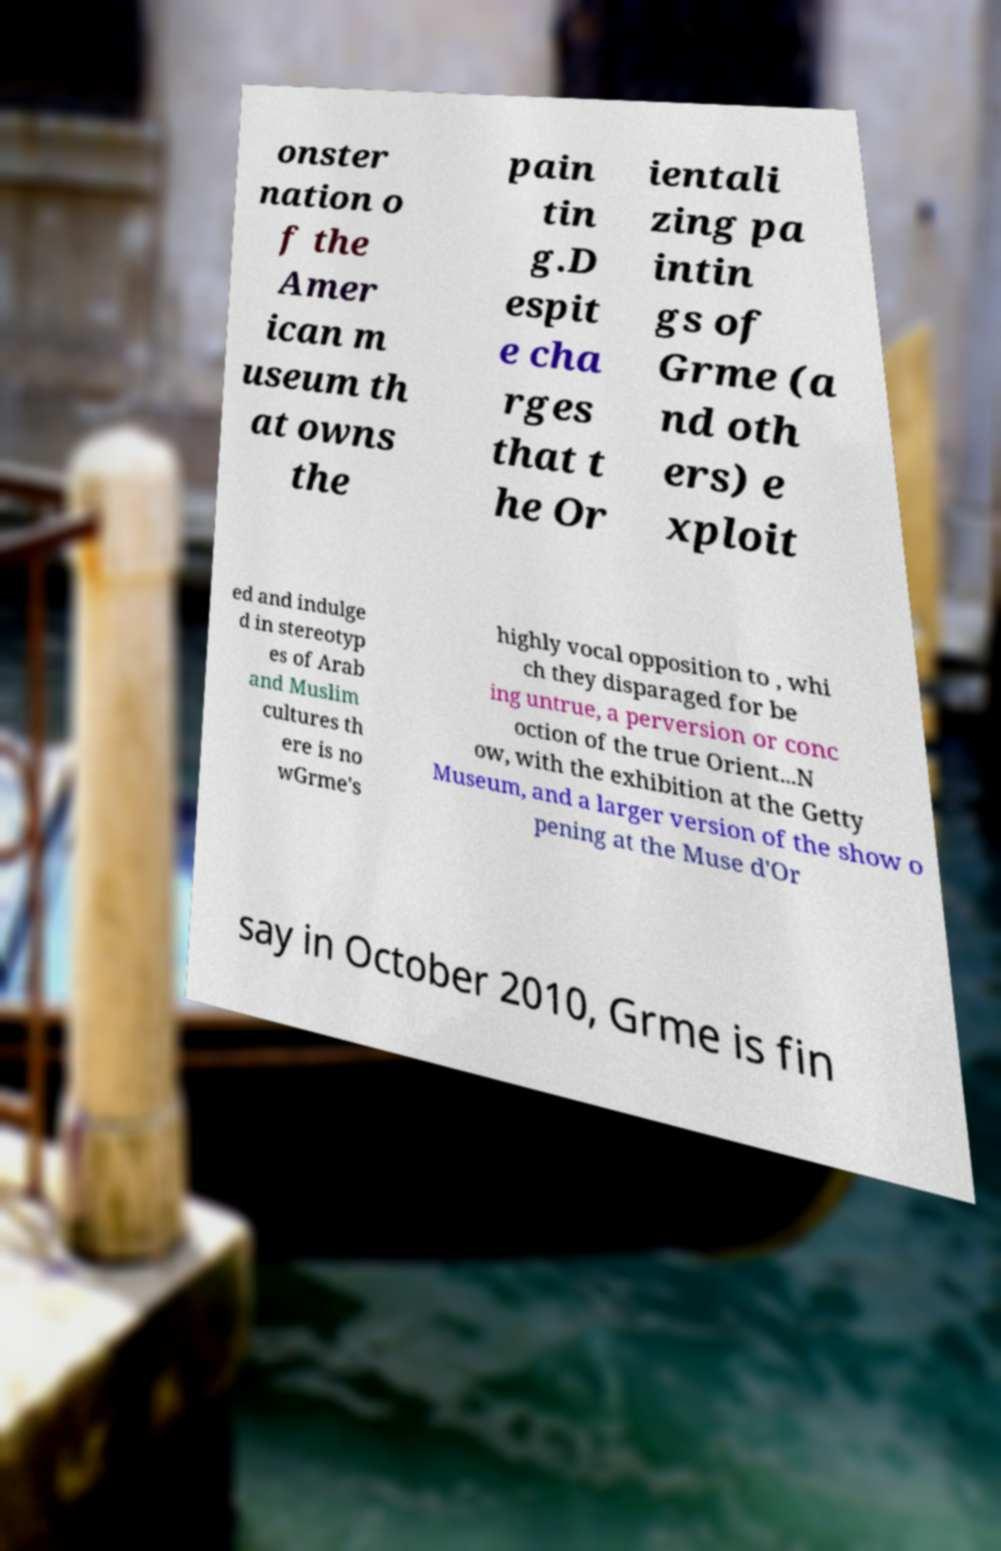Can you accurately transcribe the text from the provided image for me? onster nation o f the Amer ican m useum th at owns the pain tin g.D espit e cha rges that t he Or ientali zing pa intin gs of Grme (a nd oth ers) e xploit ed and indulge d in stereotyp es of Arab and Muslim cultures th ere is no wGrme's highly vocal opposition to , whi ch they disparaged for be ing untrue, a perversion or conc oction of the true Orient...N ow, with the exhibition at the Getty Museum, and a larger version of the show o pening at the Muse d'Or say in October 2010, Grme is fin 